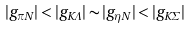<formula> <loc_0><loc_0><loc_500><loc_500>| g _ { \pi N } | < | g _ { K \Lambda } | \sim | g _ { \eta N } | < | g _ { K \Sigma } |</formula> 